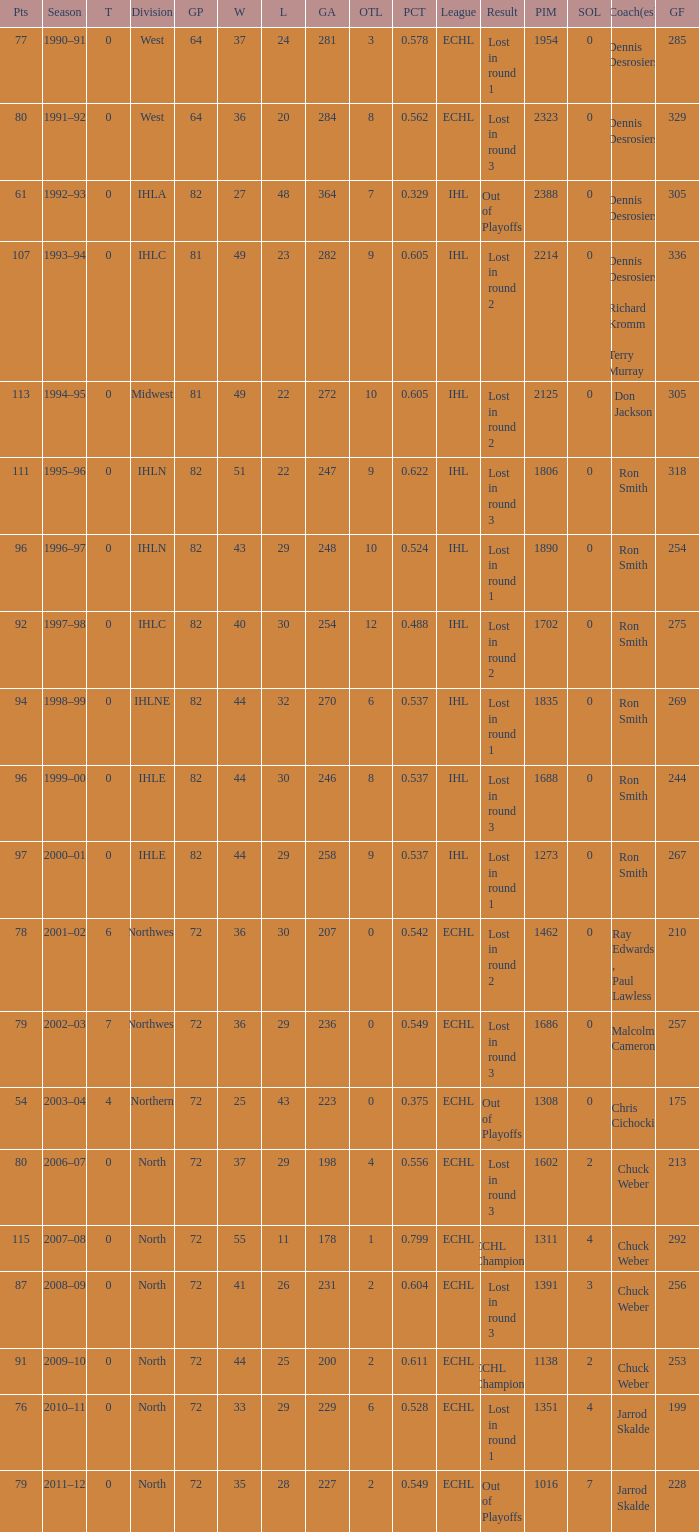What was the highest SOL where the team lost in round 3? 3.0. 